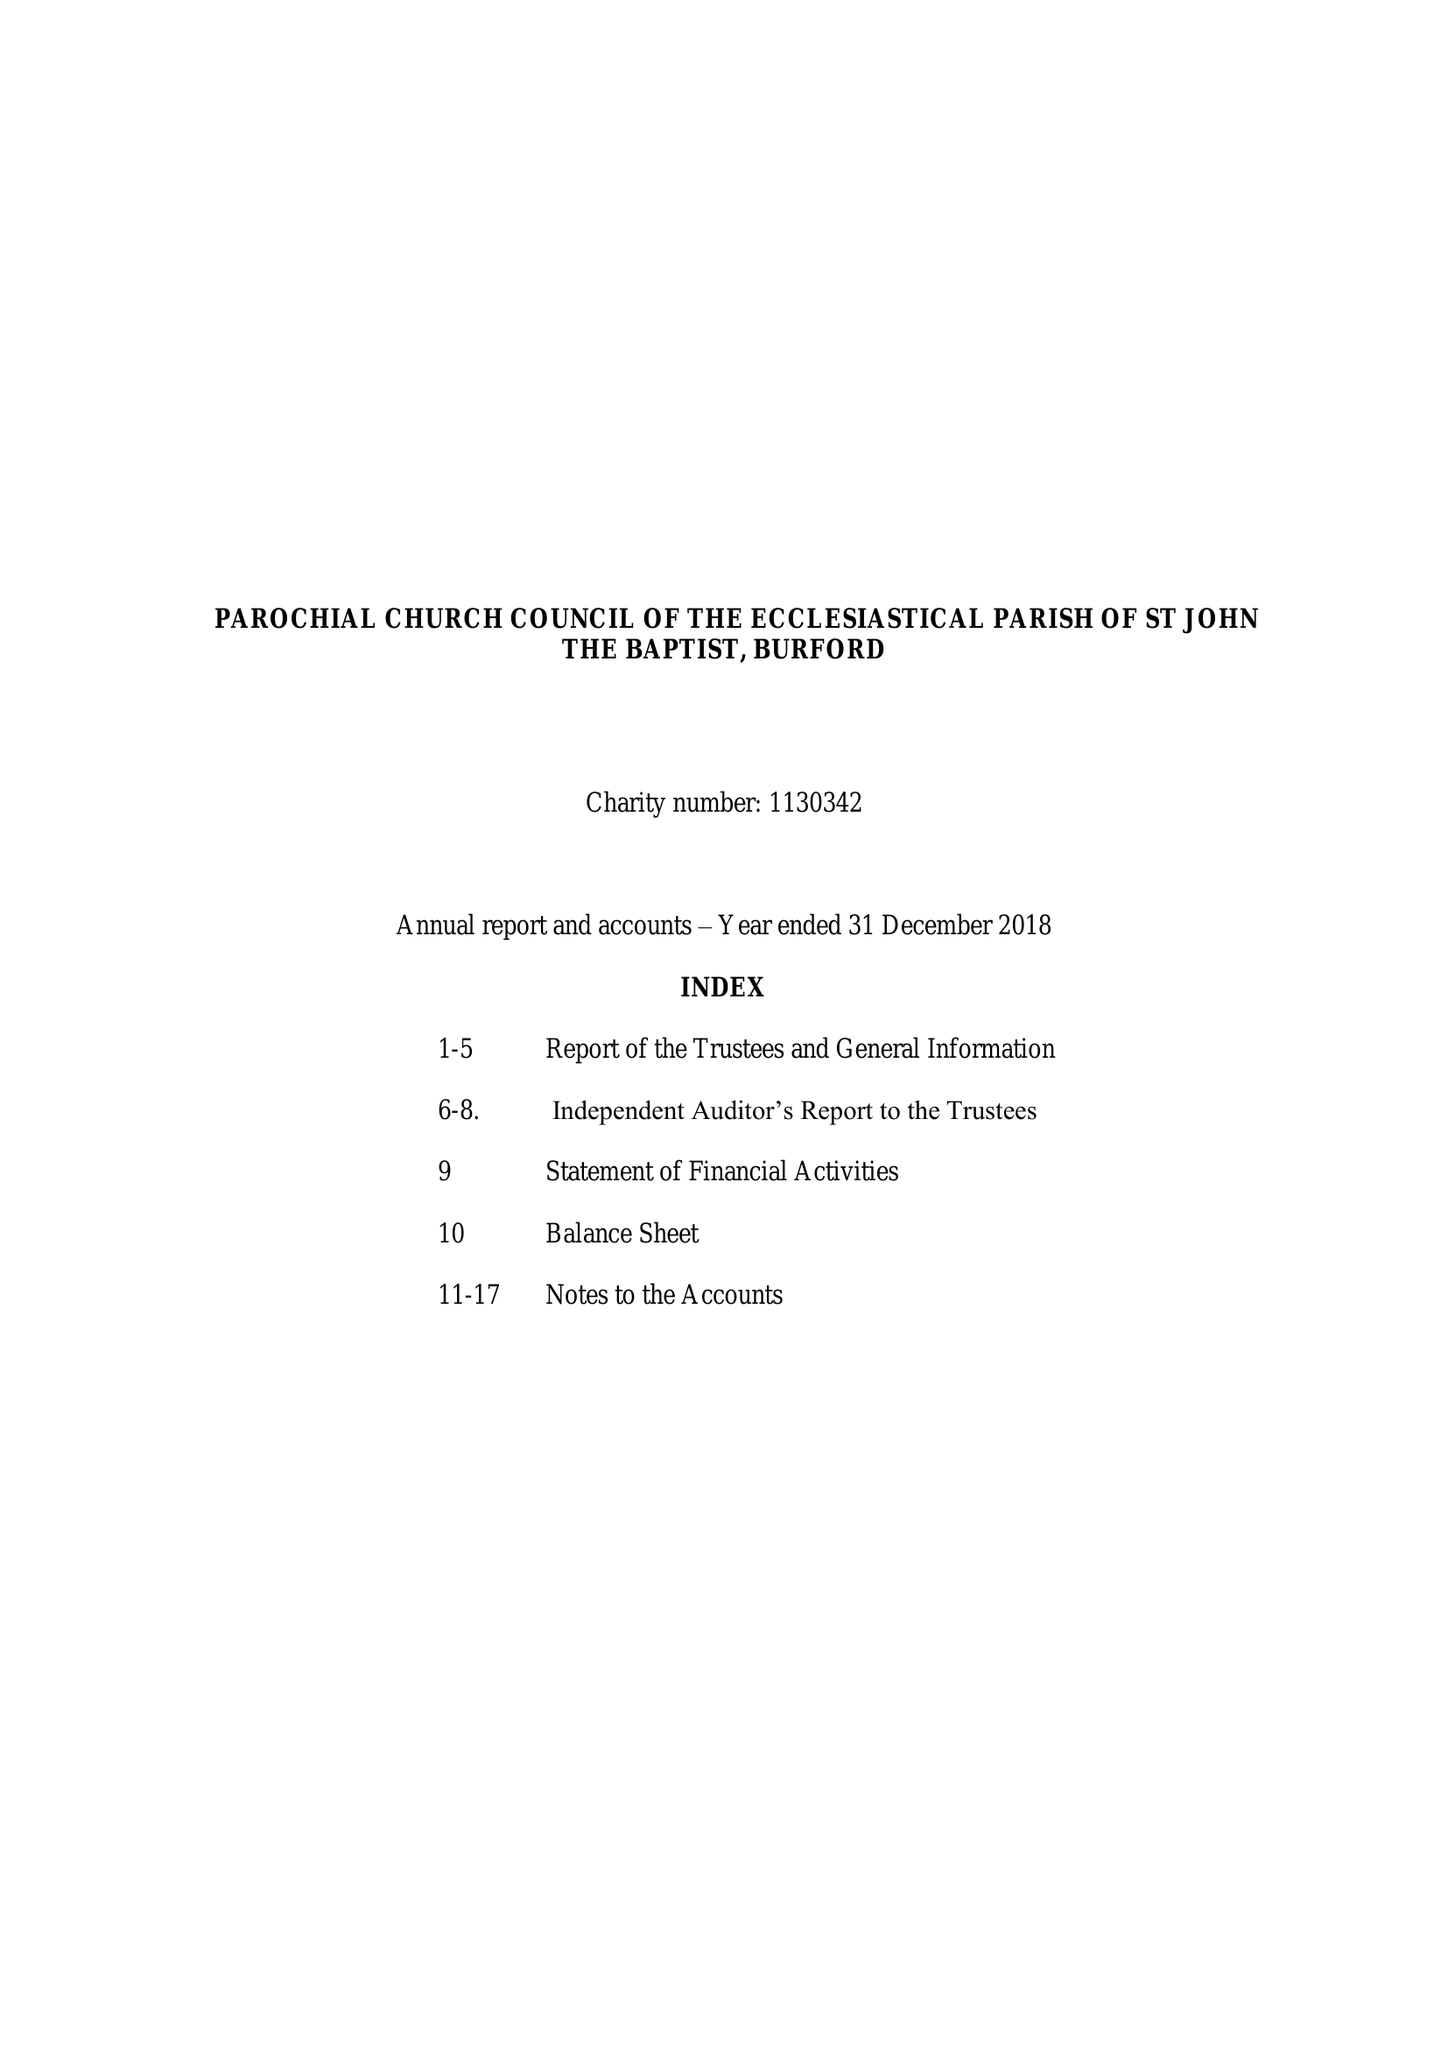What is the value for the income_annually_in_british_pounds?
Answer the question using a single word or phrase. 421005.00 